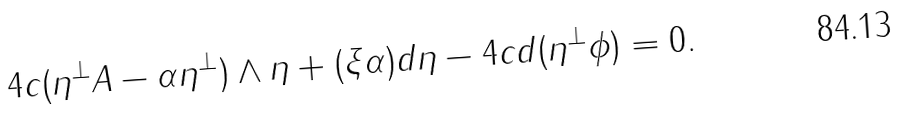<formula> <loc_0><loc_0><loc_500><loc_500>4 c ( \eta ^ { \perp } A - \alpha \eta ^ { \perp } ) \wedge \eta + ( \xi \alpha ) d \eta - 4 c d ( \eta ^ { \perp } \phi ) = 0 .</formula> 